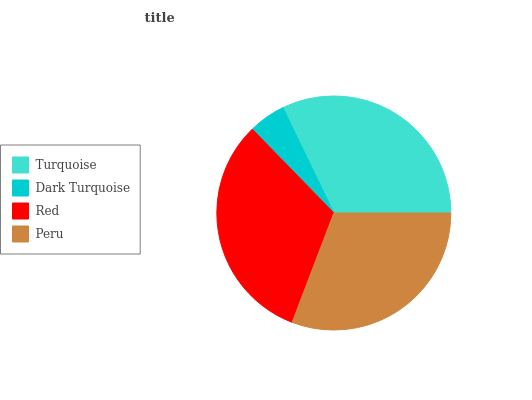Is Dark Turquoise the minimum?
Answer yes or no. Yes. Is Turquoise the maximum?
Answer yes or no. Yes. Is Red the minimum?
Answer yes or no. No. Is Red the maximum?
Answer yes or no. No. Is Red greater than Dark Turquoise?
Answer yes or no. Yes. Is Dark Turquoise less than Red?
Answer yes or no. Yes. Is Dark Turquoise greater than Red?
Answer yes or no. No. Is Red less than Dark Turquoise?
Answer yes or no. No. Is Red the high median?
Answer yes or no. Yes. Is Peru the low median?
Answer yes or no. Yes. Is Dark Turquoise the high median?
Answer yes or no. No. Is Red the low median?
Answer yes or no. No. 